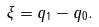Convert formula to latex. <formula><loc_0><loc_0><loc_500><loc_500>\xi = q _ { 1 } - q _ { 0 } .</formula> 